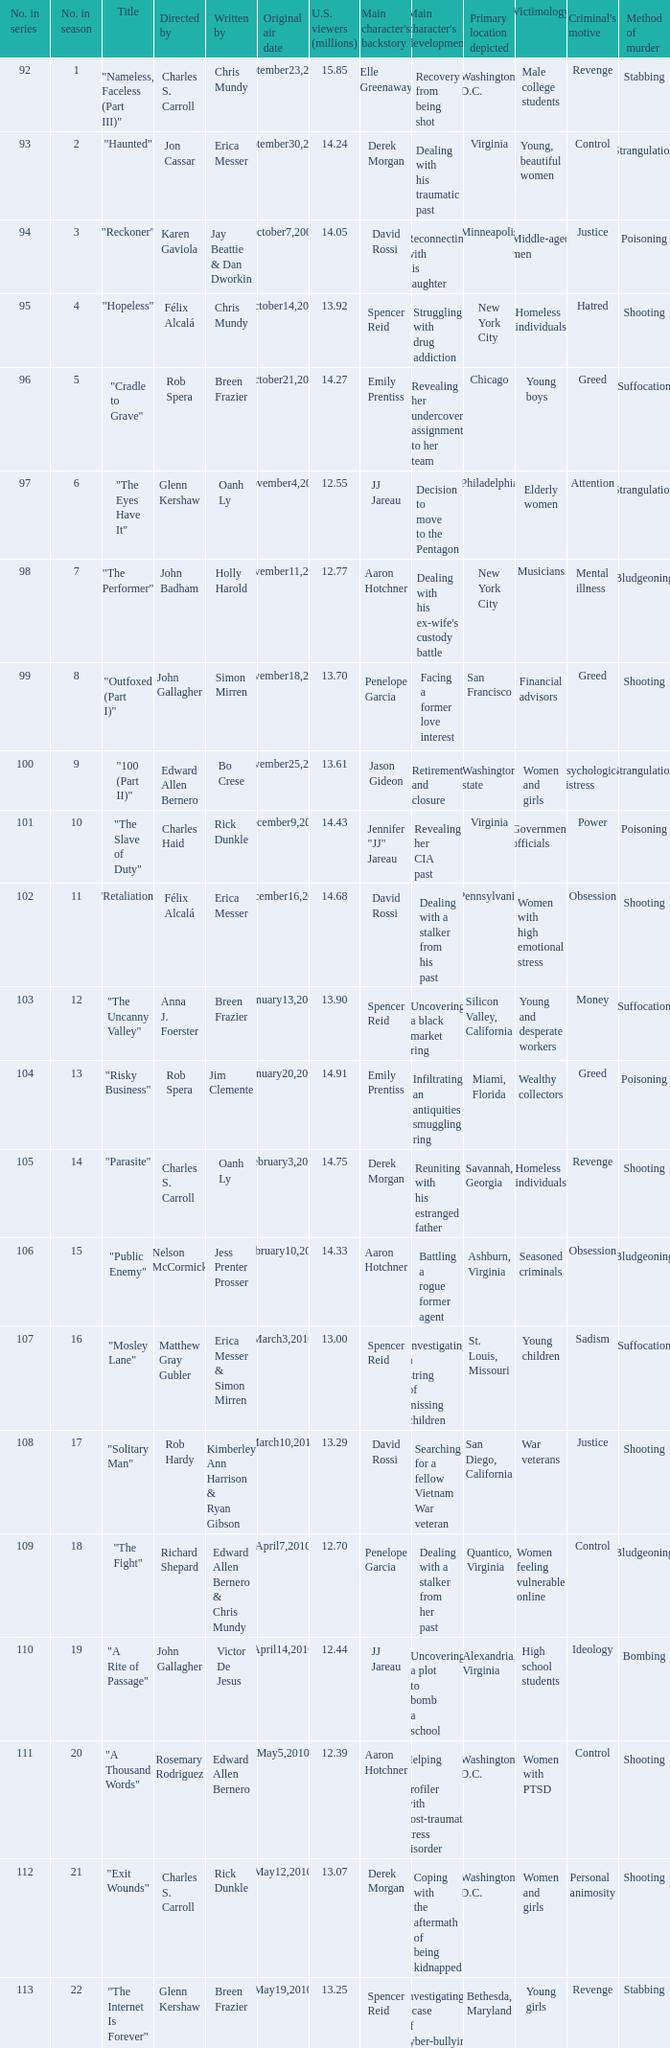What season was the episode "haunted" in? 2.0. 